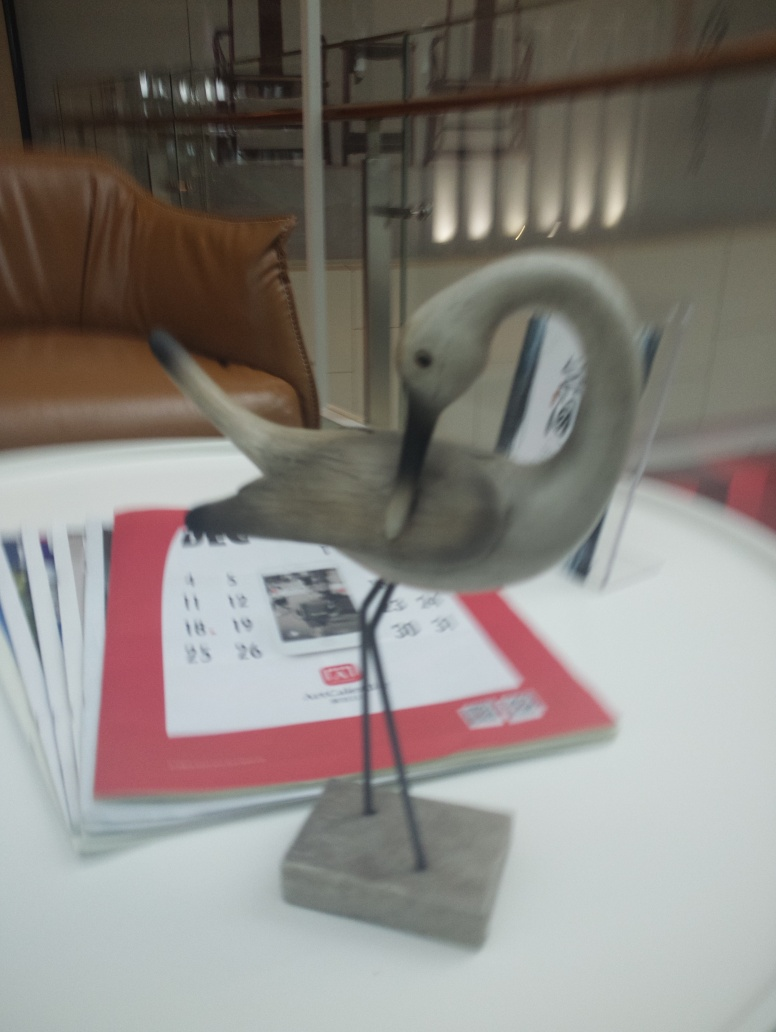Are the edges of the background unclear?
A. No
B. Yes
Answer with the option's letter from the given choices directly.
 B. 